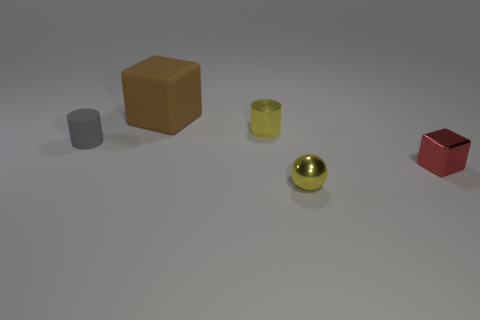Is the number of big blocks that are in front of the small red metallic block greater than the number of small cylinders that are in front of the matte cylinder?
Give a very brief answer. No. Are the tiny red object and the large brown cube made of the same material?
Your response must be concise. No. What number of small objects are to the left of the big block that is on the left side of the metallic sphere?
Your answer should be very brief. 1. Is the color of the cylinder behind the tiny gray rubber thing the same as the small shiny ball?
Keep it short and to the point. Yes. How many objects are big red cubes or objects to the left of the big rubber thing?
Offer a terse response. 1. There is a tiny yellow thing that is right of the yellow cylinder; is it the same shape as the tiny yellow object that is behind the tiny yellow sphere?
Your answer should be very brief. No. Are there any other things that are the same color as the shiny cylinder?
Provide a short and direct response. Yes. The brown object that is the same material as the small gray cylinder is what shape?
Your answer should be very brief. Cube. There is a object that is in front of the brown cube and behind the gray object; what material is it?
Provide a succinct answer. Metal. Is there any other thing that is the same size as the shiny ball?
Ensure brevity in your answer.  Yes. 